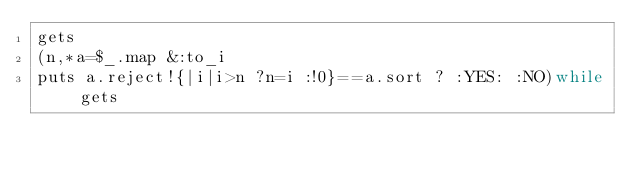Convert code to text. <code><loc_0><loc_0><loc_500><loc_500><_Ruby_>gets
(n,*a=$_.map &:to_i
puts a.reject!{|i|i>n ?n=i :!0}==a.sort ? :YES: :NO)while gets</code> 